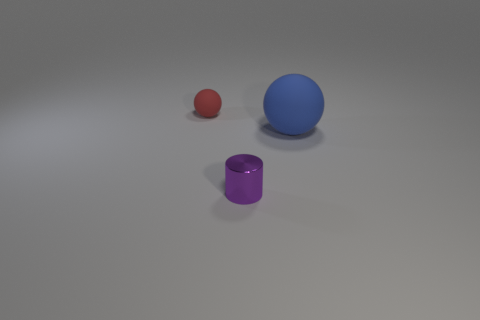Add 2 blue spheres. How many objects exist? 5 Subtract all balls. How many objects are left? 1 Add 3 blue matte objects. How many blue matte objects are left? 4 Add 3 big gray matte things. How many big gray matte things exist? 3 Subtract 0 purple blocks. How many objects are left? 3 Subtract all purple metal things. Subtract all small metallic things. How many objects are left? 1 